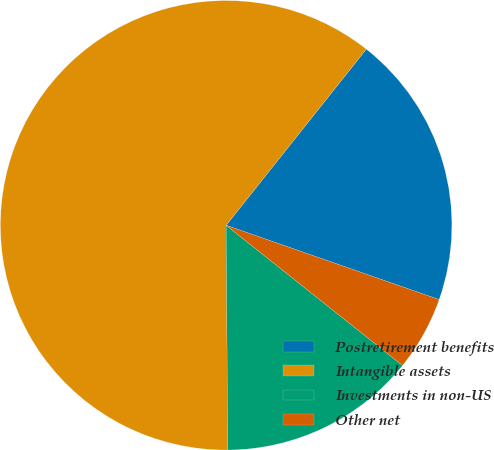Convert chart to OTSL. <chart><loc_0><loc_0><loc_500><loc_500><pie_chart><fcel>Postretirement benefits<fcel>Intangible assets<fcel>Investments in non-US<fcel>Other net<nl><fcel>19.7%<fcel>60.78%<fcel>14.16%<fcel>5.36%<nl></chart> 